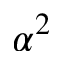<formula> <loc_0><loc_0><loc_500><loc_500>\alpha ^ { 2 }</formula> 